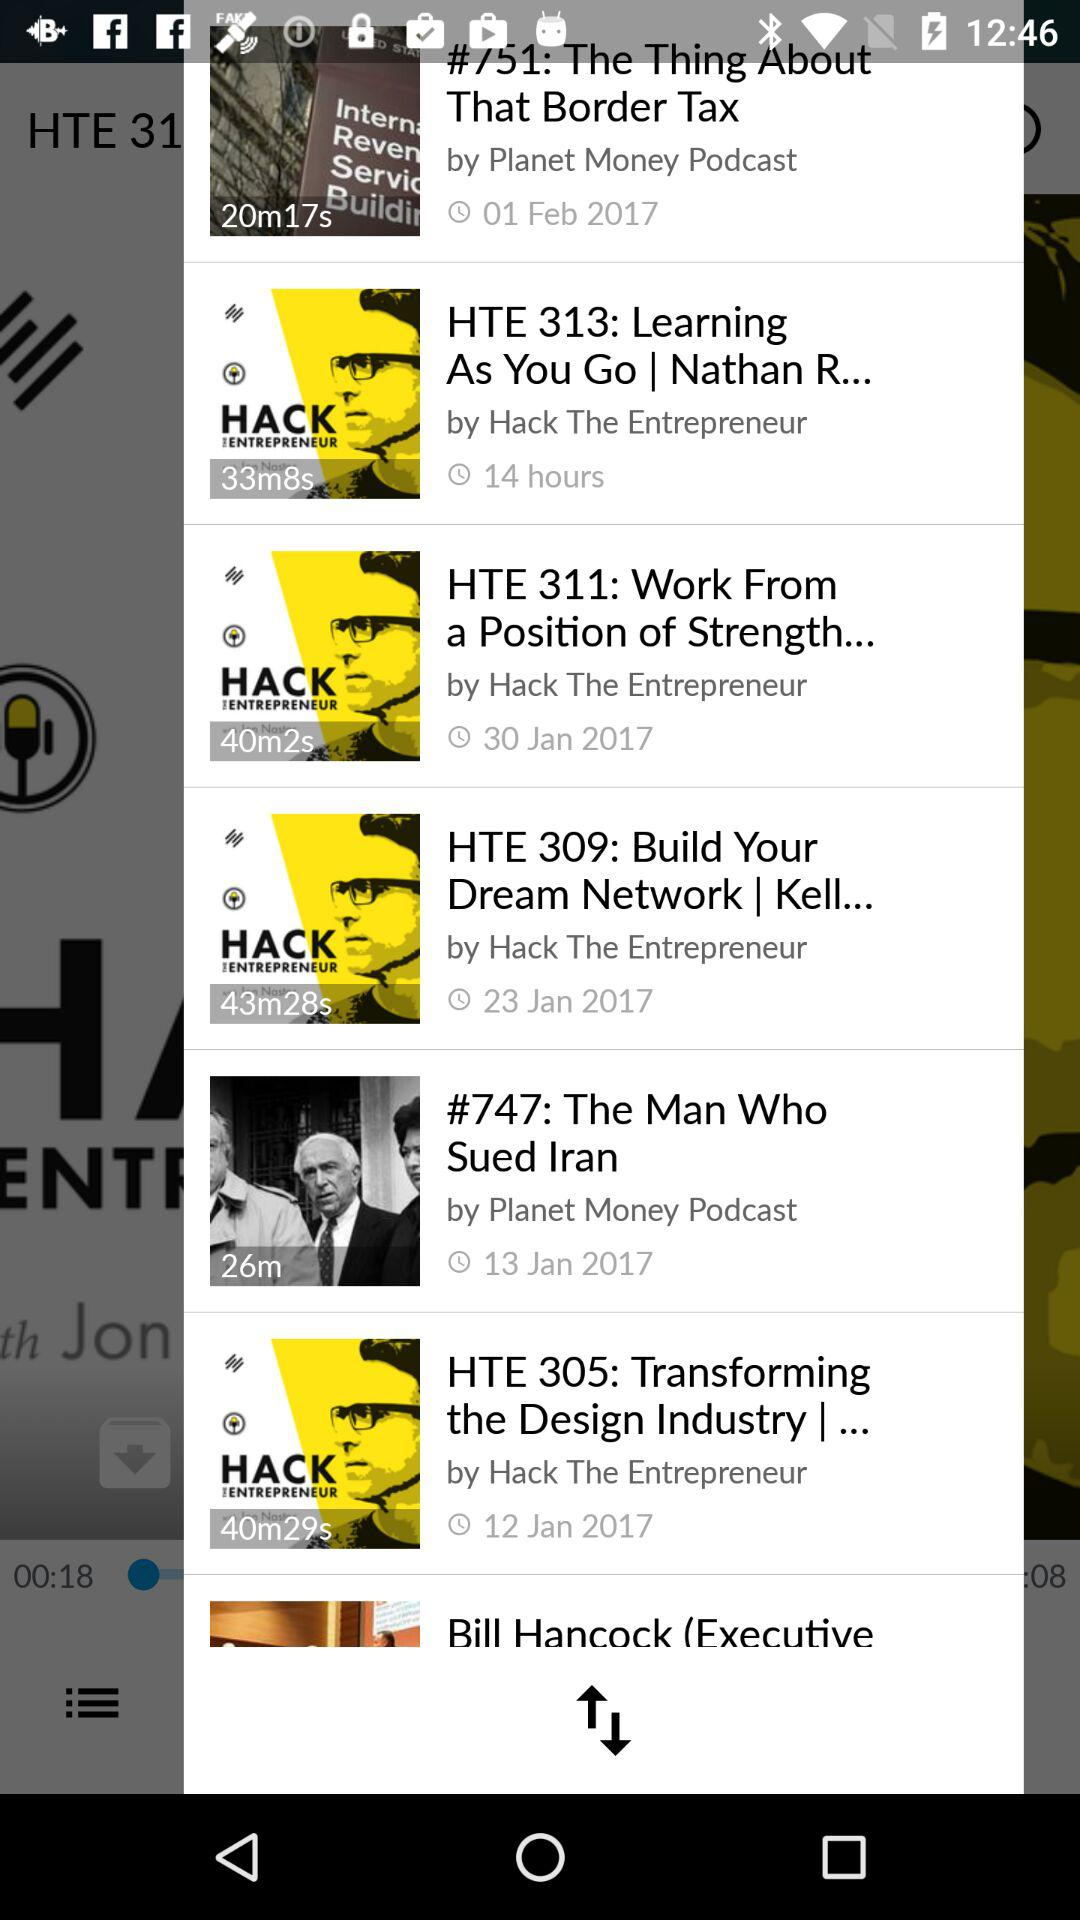By whom was "HTE 313: Learning As You Go" created? It was created by "Hack The Entrepreneur". 